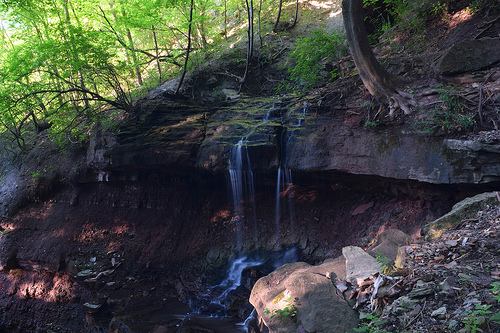<image>
Can you confirm if the waterfall is in front of the tree? Yes. The waterfall is positioned in front of the tree, appearing closer to the camera viewpoint. 